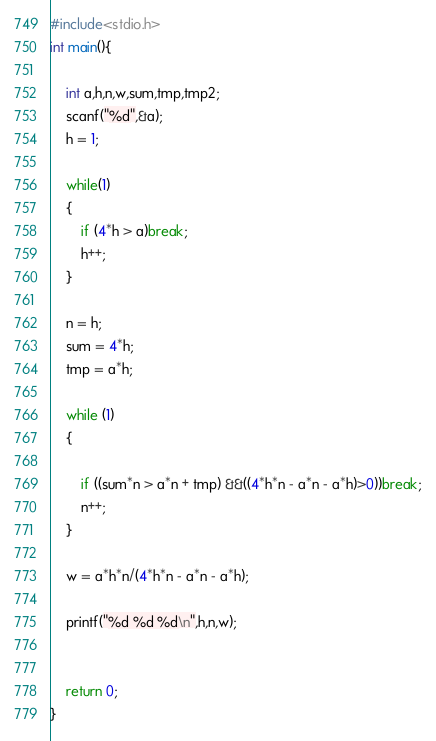<code> <loc_0><loc_0><loc_500><loc_500><_C_>#include<stdio.h>
int main(){
    
    int a,h,n,w,sum,tmp,tmp2;
    scanf("%d",&a);
    h = 1;
    
    while(1)
    {
        if (4*h > a)break;
        h++;
    }
    
    n = h;
    sum = 4*h;
    tmp = a*h;
    
    while (1)
    {
        
        if ((sum*n > a*n + tmp) &&((4*h*n - a*n - a*h)>0))break;
        n++;
    }
    
    w = a*h*n/(4*h*n - a*n - a*h);
    
    printf("%d %d %d\n",h,n,w);
    
    
    return 0;
}</code> 